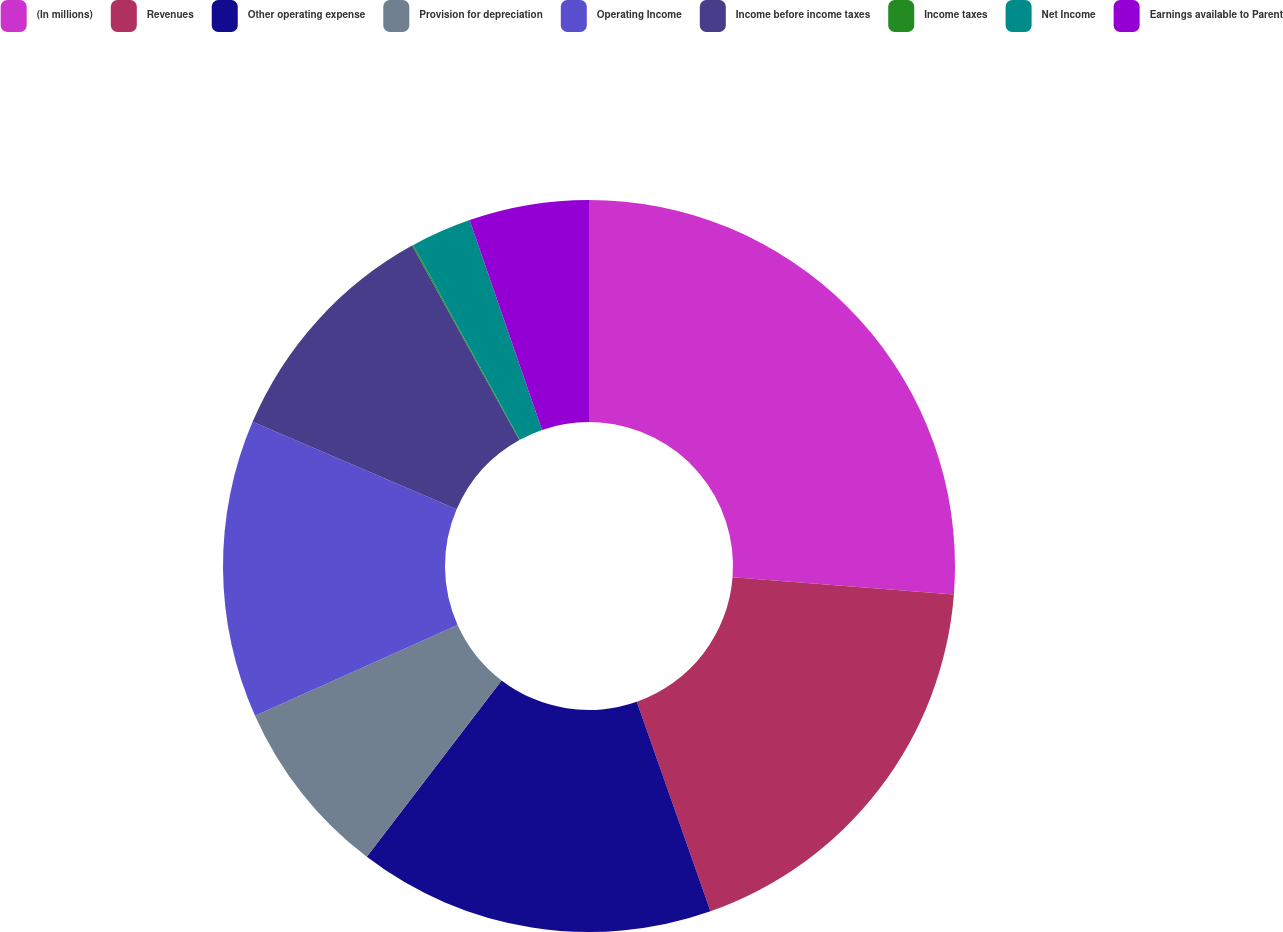Convert chart. <chart><loc_0><loc_0><loc_500><loc_500><pie_chart><fcel>(In millions)<fcel>Revenues<fcel>Other operating expense<fcel>Provision for depreciation<fcel>Operating Income<fcel>Income before income taxes<fcel>Income taxes<fcel>Net Income<fcel>Earnings available to Parent<nl><fcel>26.24%<fcel>18.38%<fcel>15.77%<fcel>7.91%<fcel>13.15%<fcel>10.53%<fcel>0.06%<fcel>2.68%<fcel>5.29%<nl></chart> 